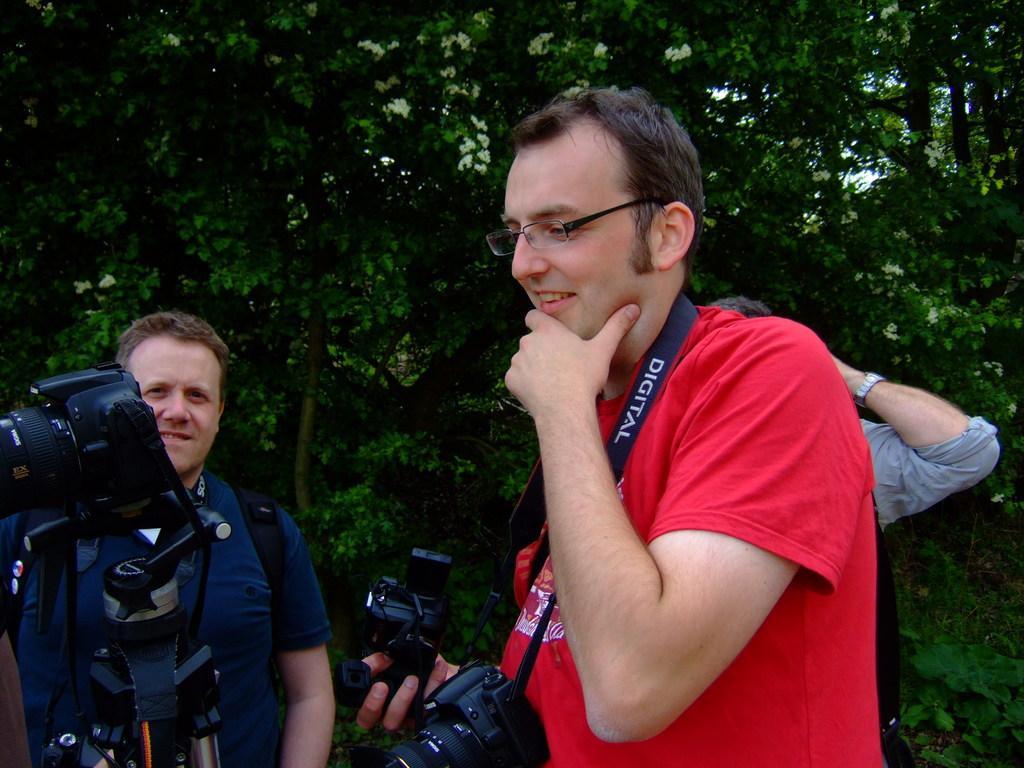Can you describe this image briefly? In this image i can see a man wearing a red shirt and he also wearing a glasses, he is holding camera in his hand and to the left corner i can see another man who is wearing a blue shirt and in the background i can see trees. 